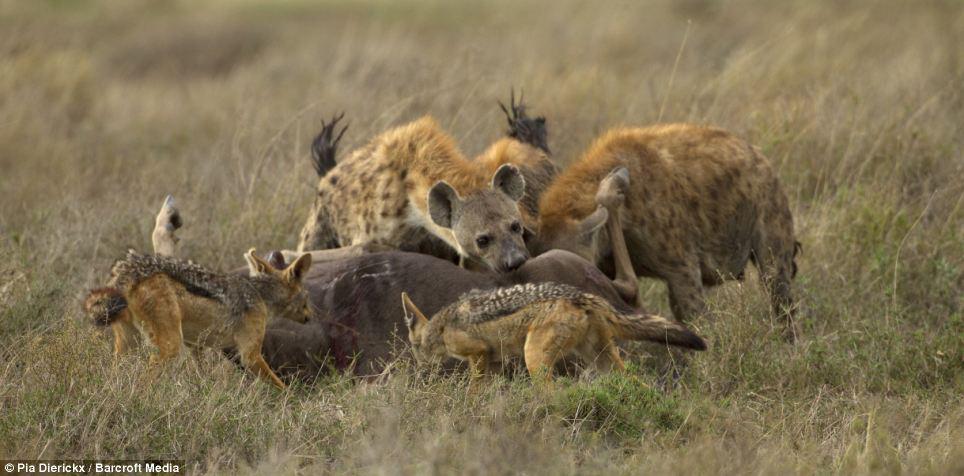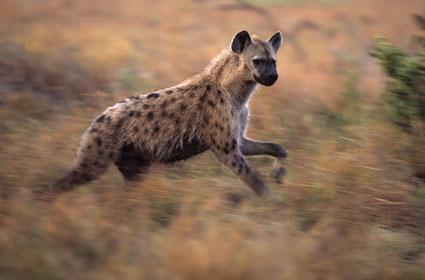The first image is the image on the left, the second image is the image on the right. Considering the images on both sides, is "The right image contains no more than two hyenas." valid? Answer yes or no. Yes. The first image is the image on the left, the second image is the image on the right. For the images shown, is this caption "An antelope is being attacked in the image on the left." true? Answer yes or no. Yes. 